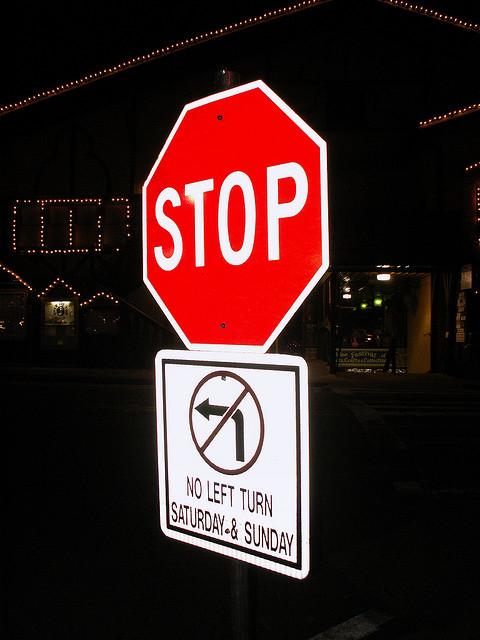What two traffic rules are illustrated?
Short answer required. Stop and no left turn. Is this the street you were looking for?
Give a very brief answer. No. What days of the week are located on the sign at the bottom?
Keep it brief. Saturday and sunday. What language is written on the sign?
Keep it brief. English. What isn't allowed on Saturday and Sunday?
Be succinct. Left turn. 